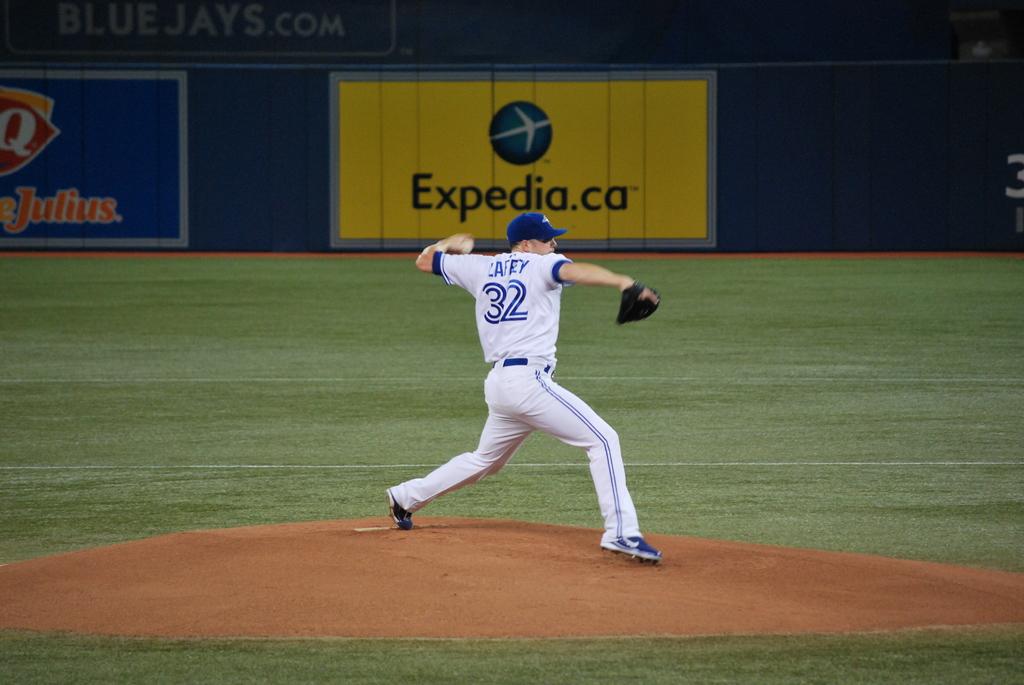What is that advertisement for in the background?
Provide a succinct answer. Expedia.ca. What number is the player?
Keep it short and to the point. 32. 